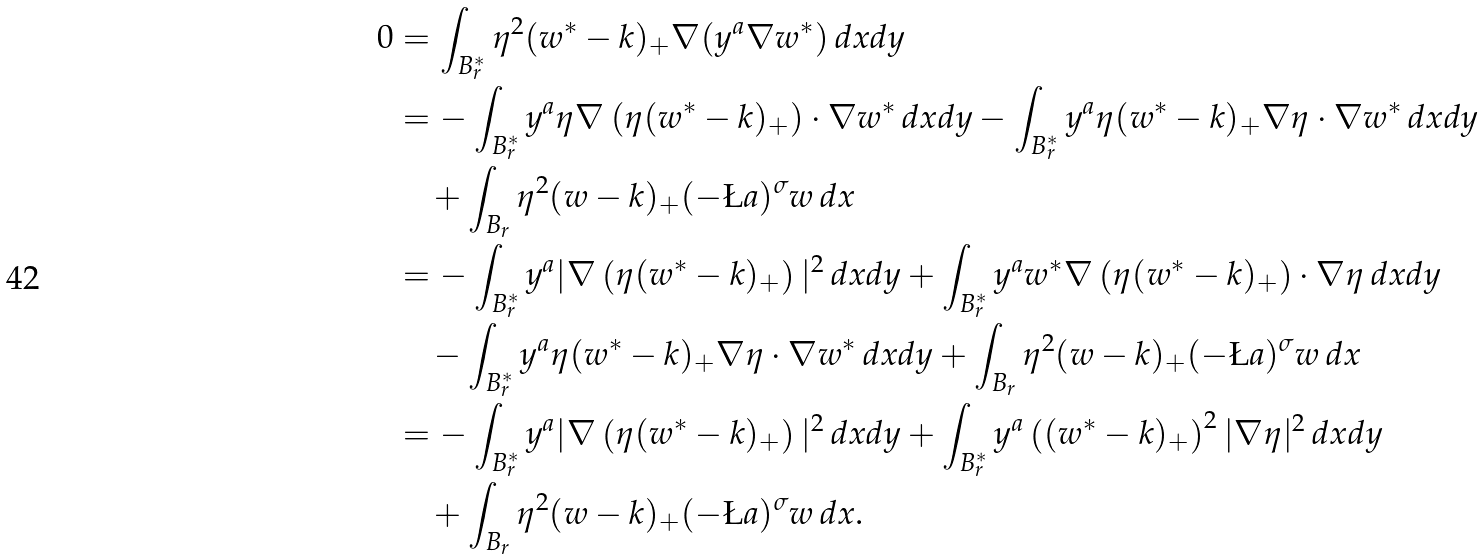<formula> <loc_0><loc_0><loc_500><loc_500>0 & = \int _ { B ^ { \ast } _ { r } } \eta ^ { 2 } ( w ^ { \ast } - k ) _ { + } \nabla ( y ^ { a } \nabla w ^ { \ast } ) \, d x d y \\ & = - \int _ { B ^ { \ast } _ { r } } y ^ { a } \eta \nabla \left ( \eta ( w ^ { \ast } - k ) _ { + } \right ) \cdot \nabla w ^ { \ast } \, d x d y - \int _ { B ^ { \ast } _ { r } } y ^ { a } \eta ( w ^ { \ast } - k ) _ { + } \nabla \eta \cdot \nabla w ^ { \ast } \, d x d y \\ & \quad + \int _ { B _ { r } } \eta ^ { 2 } ( w - k ) _ { + } ( - \L a ) ^ { \sigma } w \, d x \\ & = - \int _ { B ^ { \ast } _ { r } } y ^ { a } | \nabla \left ( \eta ( w ^ { \ast } - k ) _ { + } \right ) | ^ { 2 } \, d x d y + \int _ { B ^ { \ast } _ { r } } y ^ { a } w ^ { \ast } \nabla \left ( \eta ( w ^ { \ast } - k ) _ { + } \right ) \cdot \nabla \eta \, d x d y \\ & \quad - \int _ { B ^ { \ast } _ { r } } y ^ { a } \eta ( w ^ { \ast } - k ) _ { + } \nabla \eta \cdot \nabla w ^ { \ast } \, d x d y + \int _ { B _ { r } } \eta ^ { 2 } ( w - k ) _ { + } ( - \L a ) ^ { \sigma } w \, d x \\ & = - \int _ { B ^ { \ast } _ { r } } y ^ { a } | \nabla \left ( \eta ( w ^ { \ast } - k ) _ { + } \right ) | ^ { 2 } \, d x d y + \int _ { B ^ { \ast } _ { r } } y ^ { a } \left ( ( w ^ { \ast } - k ) _ { + } \right ) ^ { 2 } | \nabla \eta | ^ { 2 } \, d x d y \\ & \quad + \int _ { B _ { r } } \eta ^ { 2 } ( w - k ) _ { + } ( - \L a ) ^ { \sigma } w \, d x .</formula> 